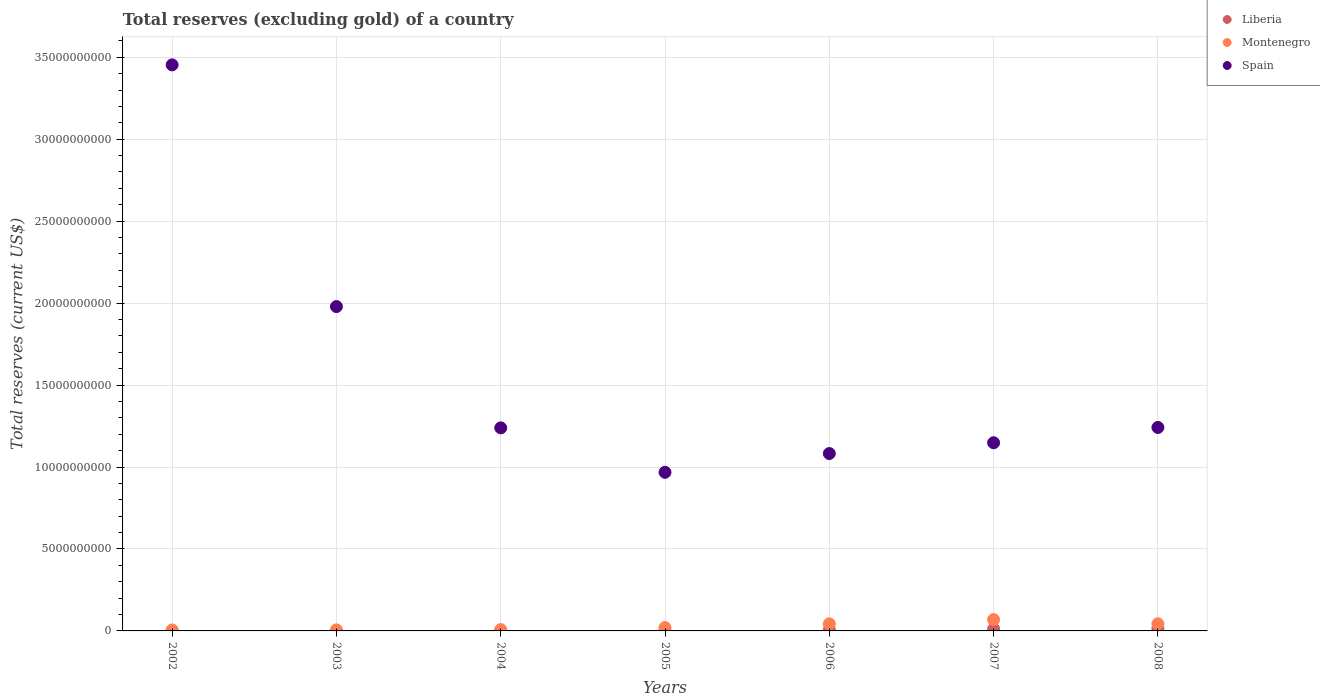Is the number of dotlines equal to the number of legend labels?
Ensure brevity in your answer.  Yes. What is the total reserves (excluding gold) in Spain in 2008?
Give a very brief answer. 1.24e+1. Across all years, what is the maximum total reserves (excluding gold) in Spain?
Offer a very short reply. 3.45e+1. Across all years, what is the minimum total reserves (excluding gold) in Spain?
Make the answer very short. 9.68e+09. In which year was the total reserves (excluding gold) in Liberia maximum?
Offer a very short reply. 2008. In which year was the total reserves (excluding gold) in Liberia minimum?
Offer a terse response. 2002. What is the total total reserves (excluding gold) in Spain in the graph?
Offer a very short reply. 1.11e+11. What is the difference between the total reserves (excluding gold) in Spain in 2007 and that in 2008?
Give a very brief answer. -9.33e+08. What is the difference between the total reserves (excluding gold) in Spain in 2006 and the total reserves (excluding gold) in Montenegro in 2007?
Your response must be concise. 1.01e+1. What is the average total reserves (excluding gold) in Liberia per year?
Offer a very short reply. 5.81e+07. In the year 2007, what is the difference between the total reserves (excluding gold) in Spain and total reserves (excluding gold) in Liberia?
Keep it short and to the point. 1.14e+1. What is the ratio of the total reserves (excluding gold) in Liberia in 2005 to that in 2006?
Make the answer very short. 0.35. What is the difference between the highest and the second highest total reserves (excluding gold) in Spain?
Provide a short and direct response. 1.47e+1. What is the difference between the highest and the lowest total reserves (excluding gold) in Liberia?
Offer a terse response. 1.58e+08. In how many years, is the total reserves (excluding gold) in Liberia greater than the average total reserves (excluding gold) in Liberia taken over all years?
Give a very brief answer. 3. Is the sum of the total reserves (excluding gold) in Montenegro in 2003 and 2007 greater than the maximum total reserves (excluding gold) in Liberia across all years?
Make the answer very short. Yes. Does the total reserves (excluding gold) in Montenegro monotonically increase over the years?
Give a very brief answer. No. Is the total reserves (excluding gold) in Montenegro strictly less than the total reserves (excluding gold) in Spain over the years?
Keep it short and to the point. Yes. How many dotlines are there?
Offer a terse response. 3. What is the difference between two consecutive major ticks on the Y-axis?
Provide a short and direct response. 5.00e+09. Are the values on the major ticks of Y-axis written in scientific E-notation?
Keep it short and to the point. No. Does the graph contain grids?
Your response must be concise. Yes. Where does the legend appear in the graph?
Your response must be concise. Top right. What is the title of the graph?
Give a very brief answer. Total reserves (excluding gold) of a country. Does "Arab World" appear as one of the legend labels in the graph?
Ensure brevity in your answer.  No. What is the label or title of the X-axis?
Your answer should be compact. Years. What is the label or title of the Y-axis?
Give a very brief answer. Total reserves (current US$). What is the Total reserves (current US$) of Liberia in 2002?
Offer a very short reply. 3.30e+06. What is the Total reserves (current US$) of Montenegro in 2002?
Make the answer very short. 5.82e+07. What is the Total reserves (current US$) in Spain in 2002?
Give a very brief answer. 3.45e+1. What is the Total reserves (current US$) of Liberia in 2003?
Ensure brevity in your answer.  7.38e+06. What is the Total reserves (current US$) in Montenegro in 2003?
Offer a terse response. 6.37e+07. What is the Total reserves (current US$) of Spain in 2003?
Give a very brief answer. 1.98e+1. What is the Total reserves (current US$) in Liberia in 2004?
Your response must be concise. 1.87e+07. What is the Total reserves (current US$) of Montenegro in 2004?
Offer a very short reply. 8.18e+07. What is the Total reserves (current US$) of Spain in 2004?
Make the answer very short. 1.24e+1. What is the Total reserves (current US$) in Liberia in 2005?
Offer a terse response. 2.54e+07. What is the Total reserves (current US$) in Montenegro in 2005?
Your response must be concise. 2.04e+08. What is the Total reserves (current US$) of Spain in 2005?
Provide a short and direct response. 9.68e+09. What is the Total reserves (current US$) in Liberia in 2006?
Your answer should be very brief. 7.20e+07. What is the Total reserves (current US$) in Montenegro in 2006?
Make the answer very short. 4.33e+08. What is the Total reserves (current US$) in Spain in 2006?
Provide a succinct answer. 1.08e+1. What is the Total reserves (current US$) of Liberia in 2007?
Your response must be concise. 1.19e+08. What is the Total reserves (current US$) in Montenegro in 2007?
Offer a very short reply. 6.89e+08. What is the Total reserves (current US$) of Spain in 2007?
Provide a succinct answer. 1.15e+1. What is the Total reserves (current US$) in Liberia in 2008?
Provide a short and direct response. 1.61e+08. What is the Total reserves (current US$) in Montenegro in 2008?
Your answer should be compact. 4.36e+08. What is the Total reserves (current US$) of Spain in 2008?
Ensure brevity in your answer.  1.24e+1. Across all years, what is the maximum Total reserves (current US$) of Liberia?
Your response must be concise. 1.61e+08. Across all years, what is the maximum Total reserves (current US$) of Montenegro?
Your response must be concise. 6.89e+08. Across all years, what is the maximum Total reserves (current US$) in Spain?
Your response must be concise. 3.45e+1. Across all years, what is the minimum Total reserves (current US$) of Liberia?
Your answer should be very brief. 3.30e+06. Across all years, what is the minimum Total reserves (current US$) of Montenegro?
Keep it short and to the point. 5.82e+07. Across all years, what is the minimum Total reserves (current US$) in Spain?
Offer a very short reply. 9.68e+09. What is the total Total reserves (current US$) in Liberia in the graph?
Keep it short and to the point. 4.07e+08. What is the total Total reserves (current US$) in Montenegro in the graph?
Make the answer very short. 1.96e+09. What is the total Total reserves (current US$) in Spain in the graph?
Your answer should be compact. 1.11e+11. What is the difference between the Total reserves (current US$) of Liberia in 2002 and that in 2003?
Your response must be concise. -4.08e+06. What is the difference between the Total reserves (current US$) of Montenegro in 2002 and that in 2003?
Your answer should be very brief. -5.52e+06. What is the difference between the Total reserves (current US$) in Spain in 2002 and that in 2003?
Give a very brief answer. 1.47e+1. What is the difference between the Total reserves (current US$) of Liberia in 2002 and that in 2004?
Ensure brevity in your answer.  -1.54e+07. What is the difference between the Total reserves (current US$) in Montenegro in 2002 and that in 2004?
Make the answer very short. -2.36e+07. What is the difference between the Total reserves (current US$) of Spain in 2002 and that in 2004?
Your answer should be compact. 2.21e+1. What is the difference between the Total reserves (current US$) of Liberia in 2002 and that in 2005?
Make the answer very short. -2.21e+07. What is the difference between the Total reserves (current US$) in Montenegro in 2002 and that in 2005?
Ensure brevity in your answer.  -1.46e+08. What is the difference between the Total reserves (current US$) of Spain in 2002 and that in 2005?
Ensure brevity in your answer.  2.49e+1. What is the difference between the Total reserves (current US$) in Liberia in 2002 and that in 2006?
Give a very brief answer. -6.87e+07. What is the difference between the Total reserves (current US$) in Montenegro in 2002 and that in 2006?
Offer a very short reply. -3.74e+08. What is the difference between the Total reserves (current US$) in Spain in 2002 and that in 2006?
Offer a terse response. 2.37e+1. What is the difference between the Total reserves (current US$) of Liberia in 2002 and that in 2007?
Give a very brief answer. -1.16e+08. What is the difference between the Total reserves (current US$) in Montenegro in 2002 and that in 2007?
Provide a short and direct response. -6.31e+08. What is the difference between the Total reserves (current US$) in Spain in 2002 and that in 2007?
Keep it short and to the point. 2.31e+1. What is the difference between the Total reserves (current US$) of Liberia in 2002 and that in 2008?
Offer a terse response. -1.58e+08. What is the difference between the Total reserves (current US$) in Montenegro in 2002 and that in 2008?
Ensure brevity in your answer.  -3.77e+08. What is the difference between the Total reserves (current US$) in Spain in 2002 and that in 2008?
Your response must be concise. 2.21e+1. What is the difference between the Total reserves (current US$) in Liberia in 2003 and that in 2004?
Offer a terse response. -1.14e+07. What is the difference between the Total reserves (current US$) in Montenegro in 2003 and that in 2004?
Offer a terse response. -1.81e+07. What is the difference between the Total reserves (current US$) of Spain in 2003 and that in 2004?
Keep it short and to the point. 7.40e+09. What is the difference between the Total reserves (current US$) of Liberia in 2003 and that in 2005?
Your answer should be compact. -1.80e+07. What is the difference between the Total reserves (current US$) in Montenegro in 2003 and that in 2005?
Offer a very short reply. -1.40e+08. What is the difference between the Total reserves (current US$) of Spain in 2003 and that in 2005?
Give a very brief answer. 1.01e+1. What is the difference between the Total reserves (current US$) in Liberia in 2003 and that in 2006?
Give a very brief answer. -6.46e+07. What is the difference between the Total reserves (current US$) in Montenegro in 2003 and that in 2006?
Keep it short and to the point. -3.69e+08. What is the difference between the Total reserves (current US$) in Spain in 2003 and that in 2006?
Offer a terse response. 8.97e+09. What is the difference between the Total reserves (current US$) of Liberia in 2003 and that in 2007?
Ensure brevity in your answer.  -1.12e+08. What is the difference between the Total reserves (current US$) in Montenegro in 2003 and that in 2007?
Your response must be concise. -6.25e+08. What is the difference between the Total reserves (current US$) in Spain in 2003 and that in 2007?
Your answer should be compact. 8.31e+09. What is the difference between the Total reserves (current US$) of Liberia in 2003 and that in 2008?
Provide a succinct answer. -1.53e+08. What is the difference between the Total reserves (current US$) in Montenegro in 2003 and that in 2008?
Your response must be concise. -3.72e+08. What is the difference between the Total reserves (current US$) in Spain in 2003 and that in 2008?
Ensure brevity in your answer.  7.37e+09. What is the difference between the Total reserves (current US$) of Liberia in 2004 and that in 2005?
Keep it short and to the point. -6.65e+06. What is the difference between the Total reserves (current US$) in Montenegro in 2004 and that in 2005?
Give a very brief answer. -1.22e+08. What is the difference between the Total reserves (current US$) in Spain in 2004 and that in 2005?
Your answer should be very brief. 2.71e+09. What is the difference between the Total reserves (current US$) of Liberia in 2004 and that in 2006?
Make the answer very short. -5.32e+07. What is the difference between the Total reserves (current US$) in Montenegro in 2004 and that in 2006?
Offer a terse response. -3.51e+08. What is the difference between the Total reserves (current US$) in Spain in 2004 and that in 2006?
Your answer should be compact. 1.57e+09. What is the difference between the Total reserves (current US$) of Liberia in 2004 and that in 2007?
Keep it short and to the point. -1.01e+08. What is the difference between the Total reserves (current US$) in Montenegro in 2004 and that in 2007?
Ensure brevity in your answer.  -6.07e+08. What is the difference between the Total reserves (current US$) of Spain in 2004 and that in 2007?
Provide a short and direct response. 9.09e+08. What is the difference between the Total reserves (current US$) in Liberia in 2004 and that in 2008?
Ensure brevity in your answer.  -1.42e+08. What is the difference between the Total reserves (current US$) of Montenegro in 2004 and that in 2008?
Make the answer very short. -3.54e+08. What is the difference between the Total reserves (current US$) of Spain in 2004 and that in 2008?
Provide a short and direct response. -2.48e+07. What is the difference between the Total reserves (current US$) of Liberia in 2005 and that in 2006?
Provide a succinct answer. -4.66e+07. What is the difference between the Total reserves (current US$) in Montenegro in 2005 and that in 2006?
Your response must be concise. -2.29e+08. What is the difference between the Total reserves (current US$) of Spain in 2005 and that in 2006?
Offer a very short reply. -1.14e+09. What is the difference between the Total reserves (current US$) of Liberia in 2005 and that in 2007?
Provide a short and direct response. -9.40e+07. What is the difference between the Total reserves (current US$) in Montenegro in 2005 and that in 2007?
Offer a terse response. -4.85e+08. What is the difference between the Total reserves (current US$) of Spain in 2005 and that in 2007?
Make the answer very short. -1.80e+09. What is the difference between the Total reserves (current US$) in Liberia in 2005 and that in 2008?
Offer a very short reply. -1.35e+08. What is the difference between the Total reserves (current US$) of Montenegro in 2005 and that in 2008?
Give a very brief answer. -2.32e+08. What is the difference between the Total reserves (current US$) of Spain in 2005 and that in 2008?
Provide a short and direct response. -2.74e+09. What is the difference between the Total reserves (current US$) in Liberia in 2006 and that in 2007?
Your response must be concise. -4.74e+07. What is the difference between the Total reserves (current US$) of Montenegro in 2006 and that in 2007?
Offer a very short reply. -2.56e+08. What is the difference between the Total reserves (current US$) in Spain in 2006 and that in 2007?
Your answer should be compact. -6.58e+08. What is the difference between the Total reserves (current US$) in Liberia in 2006 and that in 2008?
Offer a terse response. -8.89e+07. What is the difference between the Total reserves (current US$) of Montenegro in 2006 and that in 2008?
Provide a succinct answer. -3.00e+06. What is the difference between the Total reserves (current US$) of Spain in 2006 and that in 2008?
Offer a terse response. -1.59e+09. What is the difference between the Total reserves (current US$) of Liberia in 2007 and that in 2008?
Offer a terse response. -4.15e+07. What is the difference between the Total reserves (current US$) of Montenegro in 2007 and that in 2008?
Provide a short and direct response. 2.53e+08. What is the difference between the Total reserves (current US$) of Spain in 2007 and that in 2008?
Give a very brief answer. -9.33e+08. What is the difference between the Total reserves (current US$) of Liberia in 2002 and the Total reserves (current US$) of Montenegro in 2003?
Keep it short and to the point. -6.04e+07. What is the difference between the Total reserves (current US$) in Liberia in 2002 and the Total reserves (current US$) in Spain in 2003?
Provide a succinct answer. -1.98e+1. What is the difference between the Total reserves (current US$) in Montenegro in 2002 and the Total reserves (current US$) in Spain in 2003?
Keep it short and to the point. -1.97e+1. What is the difference between the Total reserves (current US$) of Liberia in 2002 and the Total reserves (current US$) of Montenegro in 2004?
Your answer should be very brief. -7.85e+07. What is the difference between the Total reserves (current US$) in Liberia in 2002 and the Total reserves (current US$) in Spain in 2004?
Your response must be concise. -1.24e+1. What is the difference between the Total reserves (current US$) in Montenegro in 2002 and the Total reserves (current US$) in Spain in 2004?
Offer a terse response. -1.23e+1. What is the difference between the Total reserves (current US$) in Liberia in 2002 and the Total reserves (current US$) in Montenegro in 2005?
Your answer should be very brief. -2.01e+08. What is the difference between the Total reserves (current US$) of Liberia in 2002 and the Total reserves (current US$) of Spain in 2005?
Offer a terse response. -9.67e+09. What is the difference between the Total reserves (current US$) of Montenegro in 2002 and the Total reserves (current US$) of Spain in 2005?
Give a very brief answer. -9.62e+09. What is the difference between the Total reserves (current US$) in Liberia in 2002 and the Total reserves (current US$) in Montenegro in 2006?
Provide a short and direct response. -4.29e+08. What is the difference between the Total reserves (current US$) in Liberia in 2002 and the Total reserves (current US$) in Spain in 2006?
Provide a short and direct response. -1.08e+1. What is the difference between the Total reserves (current US$) in Montenegro in 2002 and the Total reserves (current US$) in Spain in 2006?
Provide a succinct answer. -1.08e+1. What is the difference between the Total reserves (current US$) of Liberia in 2002 and the Total reserves (current US$) of Montenegro in 2007?
Ensure brevity in your answer.  -6.86e+08. What is the difference between the Total reserves (current US$) of Liberia in 2002 and the Total reserves (current US$) of Spain in 2007?
Offer a very short reply. -1.15e+1. What is the difference between the Total reserves (current US$) in Montenegro in 2002 and the Total reserves (current US$) in Spain in 2007?
Give a very brief answer. -1.14e+1. What is the difference between the Total reserves (current US$) of Liberia in 2002 and the Total reserves (current US$) of Montenegro in 2008?
Offer a terse response. -4.32e+08. What is the difference between the Total reserves (current US$) of Liberia in 2002 and the Total reserves (current US$) of Spain in 2008?
Your response must be concise. -1.24e+1. What is the difference between the Total reserves (current US$) of Montenegro in 2002 and the Total reserves (current US$) of Spain in 2008?
Make the answer very short. -1.24e+1. What is the difference between the Total reserves (current US$) in Liberia in 2003 and the Total reserves (current US$) in Montenegro in 2004?
Provide a succinct answer. -7.44e+07. What is the difference between the Total reserves (current US$) in Liberia in 2003 and the Total reserves (current US$) in Spain in 2004?
Keep it short and to the point. -1.24e+1. What is the difference between the Total reserves (current US$) in Montenegro in 2003 and the Total reserves (current US$) in Spain in 2004?
Your answer should be compact. -1.23e+1. What is the difference between the Total reserves (current US$) of Liberia in 2003 and the Total reserves (current US$) of Montenegro in 2005?
Offer a very short reply. -1.97e+08. What is the difference between the Total reserves (current US$) in Liberia in 2003 and the Total reserves (current US$) in Spain in 2005?
Make the answer very short. -9.67e+09. What is the difference between the Total reserves (current US$) in Montenegro in 2003 and the Total reserves (current US$) in Spain in 2005?
Your answer should be very brief. -9.61e+09. What is the difference between the Total reserves (current US$) of Liberia in 2003 and the Total reserves (current US$) of Montenegro in 2006?
Offer a terse response. -4.25e+08. What is the difference between the Total reserves (current US$) of Liberia in 2003 and the Total reserves (current US$) of Spain in 2006?
Provide a succinct answer. -1.08e+1. What is the difference between the Total reserves (current US$) of Montenegro in 2003 and the Total reserves (current US$) of Spain in 2006?
Your response must be concise. -1.08e+1. What is the difference between the Total reserves (current US$) in Liberia in 2003 and the Total reserves (current US$) in Montenegro in 2007?
Provide a short and direct response. -6.81e+08. What is the difference between the Total reserves (current US$) of Liberia in 2003 and the Total reserves (current US$) of Spain in 2007?
Your response must be concise. -1.15e+1. What is the difference between the Total reserves (current US$) of Montenegro in 2003 and the Total reserves (current US$) of Spain in 2007?
Your response must be concise. -1.14e+1. What is the difference between the Total reserves (current US$) of Liberia in 2003 and the Total reserves (current US$) of Montenegro in 2008?
Provide a succinct answer. -4.28e+08. What is the difference between the Total reserves (current US$) of Liberia in 2003 and the Total reserves (current US$) of Spain in 2008?
Your answer should be compact. -1.24e+1. What is the difference between the Total reserves (current US$) in Montenegro in 2003 and the Total reserves (current US$) in Spain in 2008?
Make the answer very short. -1.23e+1. What is the difference between the Total reserves (current US$) in Liberia in 2004 and the Total reserves (current US$) in Montenegro in 2005?
Your answer should be very brief. -1.85e+08. What is the difference between the Total reserves (current US$) of Liberia in 2004 and the Total reserves (current US$) of Spain in 2005?
Your answer should be compact. -9.66e+09. What is the difference between the Total reserves (current US$) of Montenegro in 2004 and the Total reserves (current US$) of Spain in 2005?
Provide a short and direct response. -9.60e+09. What is the difference between the Total reserves (current US$) of Liberia in 2004 and the Total reserves (current US$) of Montenegro in 2006?
Provide a succinct answer. -4.14e+08. What is the difference between the Total reserves (current US$) of Liberia in 2004 and the Total reserves (current US$) of Spain in 2006?
Offer a terse response. -1.08e+1. What is the difference between the Total reserves (current US$) in Montenegro in 2004 and the Total reserves (current US$) in Spain in 2006?
Provide a succinct answer. -1.07e+1. What is the difference between the Total reserves (current US$) of Liberia in 2004 and the Total reserves (current US$) of Montenegro in 2007?
Offer a terse response. -6.70e+08. What is the difference between the Total reserves (current US$) of Liberia in 2004 and the Total reserves (current US$) of Spain in 2007?
Your response must be concise. -1.15e+1. What is the difference between the Total reserves (current US$) in Montenegro in 2004 and the Total reserves (current US$) in Spain in 2007?
Make the answer very short. -1.14e+1. What is the difference between the Total reserves (current US$) in Liberia in 2004 and the Total reserves (current US$) in Montenegro in 2008?
Ensure brevity in your answer.  -4.17e+08. What is the difference between the Total reserves (current US$) of Liberia in 2004 and the Total reserves (current US$) of Spain in 2008?
Ensure brevity in your answer.  -1.24e+1. What is the difference between the Total reserves (current US$) in Montenegro in 2004 and the Total reserves (current US$) in Spain in 2008?
Ensure brevity in your answer.  -1.23e+1. What is the difference between the Total reserves (current US$) in Liberia in 2005 and the Total reserves (current US$) in Montenegro in 2006?
Provide a short and direct response. -4.07e+08. What is the difference between the Total reserves (current US$) in Liberia in 2005 and the Total reserves (current US$) in Spain in 2006?
Keep it short and to the point. -1.08e+1. What is the difference between the Total reserves (current US$) of Montenegro in 2005 and the Total reserves (current US$) of Spain in 2006?
Your response must be concise. -1.06e+1. What is the difference between the Total reserves (current US$) in Liberia in 2005 and the Total reserves (current US$) in Montenegro in 2007?
Your response must be concise. -6.63e+08. What is the difference between the Total reserves (current US$) of Liberia in 2005 and the Total reserves (current US$) of Spain in 2007?
Provide a short and direct response. -1.15e+1. What is the difference between the Total reserves (current US$) of Montenegro in 2005 and the Total reserves (current US$) of Spain in 2007?
Your response must be concise. -1.13e+1. What is the difference between the Total reserves (current US$) of Liberia in 2005 and the Total reserves (current US$) of Montenegro in 2008?
Give a very brief answer. -4.10e+08. What is the difference between the Total reserves (current US$) of Liberia in 2005 and the Total reserves (current US$) of Spain in 2008?
Ensure brevity in your answer.  -1.24e+1. What is the difference between the Total reserves (current US$) in Montenegro in 2005 and the Total reserves (current US$) in Spain in 2008?
Offer a terse response. -1.22e+1. What is the difference between the Total reserves (current US$) of Liberia in 2006 and the Total reserves (current US$) of Montenegro in 2007?
Offer a terse response. -6.17e+08. What is the difference between the Total reserves (current US$) in Liberia in 2006 and the Total reserves (current US$) in Spain in 2007?
Make the answer very short. -1.14e+1. What is the difference between the Total reserves (current US$) in Montenegro in 2006 and the Total reserves (current US$) in Spain in 2007?
Offer a terse response. -1.10e+1. What is the difference between the Total reserves (current US$) in Liberia in 2006 and the Total reserves (current US$) in Montenegro in 2008?
Offer a very short reply. -3.64e+08. What is the difference between the Total reserves (current US$) of Liberia in 2006 and the Total reserves (current US$) of Spain in 2008?
Keep it short and to the point. -1.23e+1. What is the difference between the Total reserves (current US$) in Montenegro in 2006 and the Total reserves (current US$) in Spain in 2008?
Your answer should be very brief. -1.20e+1. What is the difference between the Total reserves (current US$) of Liberia in 2007 and the Total reserves (current US$) of Montenegro in 2008?
Your answer should be compact. -3.16e+08. What is the difference between the Total reserves (current US$) of Liberia in 2007 and the Total reserves (current US$) of Spain in 2008?
Make the answer very short. -1.23e+1. What is the difference between the Total reserves (current US$) in Montenegro in 2007 and the Total reserves (current US$) in Spain in 2008?
Offer a terse response. -1.17e+1. What is the average Total reserves (current US$) in Liberia per year?
Your answer should be very brief. 5.81e+07. What is the average Total reserves (current US$) of Montenegro per year?
Make the answer very short. 2.81e+08. What is the average Total reserves (current US$) in Spain per year?
Give a very brief answer. 1.59e+1. In the year 2002, what is the difference between the Total reserves (current US$) of Liberia and Total reserves (current US$) of Montenegro?
Keep it short and to the point. -5.49e+07. In the year 2002, what is the difference between the Total reserves (current US$) in Liberia and Total reserves (current US$) in Spain?
Ensure brevity in your answer.  -3.45e+1. In the year 2002, what is the difference between the Total reserves (current US$) in Montenegro and Total reserves (current US$) in Spain?
Offer a terse response. -3.45e+1. In the year 2003, what is the difference between the Total reserves (current US$) of Liberia and Total reserves (current US$) of Montenegro?
Give a very brief answer. -5.63e+07. In the year 2003, what is the difference between the Total reserves (current US$) of Liberia and Total reserves (current US$) of Spain?
Give a very brief answer. -1.98e+1. In the year 2003, what is the difference between the Total reserves (current US$) of Montenegro and Total reserves (current US$) of Spain?
Provide a succinct answer. -1.97e+1. In the year 2004, what is the difference between the Total reserves (current US$) of Liberia and Total reserves (current US$) of Montenegro?
Your answer should be compact. -6.31e+07. In the year 2004, what is the difference between the Total reserves (current US$) of Liberia and Total reserves (current US$) of Spain?
Offer a terse response. -1.24e+1. In the year 2004, what is the difference between the Total reserves (current US$) in Montenegro and Total reserves (current US$) in Spain?
Your answer should be very brief. -1.23e+1. In the year 2005, what is the difference between the Total reserves (current US$) of Liberia and Total reserves (current US$) of Montenegro?
Offer a very short reply. -1.79e+08. In the year 2005, what is the difference between the Total reserves (current US$) of Liberia and Total reserves (current US$) of Spain?
Provide a short and direct response. -9.65e+09. In the year 2005, what is the difference between the Total reserves (current US$) of Montenegro and Total reserves (current US$) of Spain?
Provide a succinct answer. -9.47e+09. In the year 2006, what is the difference between the Total reserves (current US$) in Liberia and Total reserves (current US$) in Montenegro?
Keep it short and to the point. -3.61e+08. In the year 2006, what is the difference between the Total reserves (current US$) of Liberia and Total reserves (current US$) of Spain?
Offer a terse response. -1.08e+1. In the year 2006, what is the difference between the Total reserves (current US$) of Montenegro and Total reserves (current US$) of Spain?
Provide a short and direct response. -1.04e+1. In the year 2007, what is the difference between the Total reserves (current US$) in Liberia and Total reserves (current US$) in Montenegro?
Give a very brief answer. -5.69e+08. In the year 2007, what is the difference between the Total reserves (current US$) in Liberia and Total reserves (current US$) in Spain?
Your response must be concise. -1.14e+1. In the year 2007, what is the difference between the Total reserves (current US$) in Montenegro and Total reserves (current US$) in Spain?
Offer a terse response. -1.08e+1. In the year 2008, what is the difference between the Total reserves (current US$) in Liberia and Total reserves (current US$) in Montenegro?
Make the answer very short. -2.75e+08. In the year 2008, what is the difference between the Total reserves (current US$) of Liberia and Total reserves (current US$) of Spain?
Ensure brevity in your answer.  -1.23e+1. In the year 2008, what is the difference between the Total reserves (current US$) in Montenegro and Total reserves (current US$) in Spain?
Your answer should be very brief. -1.20e+1. What is the ratio of the Total reserves (current US$) in Liberia in 2002 to that in 2003?
Provide a succinct answer. 0.45. What is the ratio of the Total reserves (current US$) in Montenegro in 2002 to that in 2003?
Provide a short and direct response. 0.91. What is the ratio of the Total reserves (current US$) of Spain in 2002 to that in 2003?
Provide a succinct answer. 1.75. What is the ratio of the Total reserves (current US$) in Liberia in 2002 to that in 2004?
Make the answer very short. 0.18. What is the ratio of the Total reserves (current US$) of Montenegro in 2002 to that in 2004?
Your answer should be compact. 0.71. What is the ratio of the Total reserves (current US$) of Spain in 2002 to that in 2004?
Provide a short and direct response. 2.79. What is the ratio of the Total reserves (current US$) of Liberia in 2002 to that in 2005?
Make the answer very short. 0.13. What is the ratio of the Total reserves (current US$) of Montenegro in 2002 to that in 2005?
Ensure brevity in your answer.  0.29. What is the ratio of the Total reserves (current US$) in Spain in 2002 to that in 2005?
Offer a very short reply. 3.57. What is the ratio of the Total reserves (current US$) in Liberia in 2002 to that in 2006?
Provide a short and direct response. 0.05. What is the ratio of the Total reserves (current US$) of Montenegro in 2002 to that in 2006?
Your answer should be compact. 0.13. What is the ratio of the Total reserves (current US$) in Spain in 2002 to that in 2006?
Your answer should be very brief. 3.19. What is the ratio of the Total reserves (current US$) in Liberia in 2002 to that in 2007?
Offer a very short reply. 0.03. What is the ratio of the Total reserves (current US$) in Montenegro in 2002 to that in 2007?
Your answer should be very brief. 0.08. What is the ratio of the Total reserves (current US$) of Spain in 2002 to that in 2007?
Offer a very short reply. 3.01. What is the ratio of the Total reserves (current US$) of Liberia in 2002 to that in 2008?
Ensure brevity in your answer.  0.02. What is the ratio of the Total reserves (current US$) of Montenegro in 2002 to that in 2008?
Your answer should be compact. 0.13. What is the ratio of the Total reserves (current US$) in Spain in 2002 to that in 2008?
Ensure brevity in your answer.  2.78. What is the ratio of the Total reserves (current US$) in Liberia in 2003 to that in 2004?
Your response must be concise. 0.39. What is the ratio of the Total reserves (current US$) in Montenegro in 2003 to that in 2004?
Offer a very short reply. 0.78. What is the ratio of the Total reserves (current US$) of Spain in 2003 to that in 2004?
Provide a succinct answer. 1.6. What is the ratio of the Total reserves (current US$) in Liberia in 2003 to that in 2005?
Your response must be concise. 0.29. What is the ratio of the Total reserves (current US$) in Montenegro in 2003 to that in 2005?
Your response must be concise. 0.31. What is the ratio of the Total reserves (current US$) of Spain in 2003 to that in 2005?
Your answer should be compact. 2.04. What is the ratio of the Total reserves (current US$) of Liberia in 2003 to that in 2006?
Your answer should be compact. 0.1. What is the ratio of the Total reserves (current US$) in Montenegro in 2003 to that in 2006?
Provide a short and direct response. 0.15. What is the ratio of the Total reserves (current US$) of Spain in 2003 to that in 2006?
Provide a succinct answer. 1.83. What is the ratio of the Total reserves (current US$) in Liberia in 2003 to that in 2007?
Provide a short and direct response. 0.06. What is the ratio of the Total reserves (current US$) in Montenegro in 2003 to that in 2007?
Offer a terse response. 0.09. What is the ratio of the Total reserves (current US$) in Spain in 2003 to that in 2007?
Your response must be concise. 1.72. What is the ratio of the Total reserves (current US$) in Liberia in 2003 to that in 2008?
Offer a very short reply. 0.05. What is the ratio of the Total reserves (current US$) in Montenegro in 2003 to that in 2008?
Your answer should be compact. 0.15. What is the ratio of the Total reserves (current US$) of Spain in 2003 to that in 2008?
Keep it short and to the point. 1.59. What is the ratio of the Total reserves (current US$) of Liberia in 2004 to that in 2005?
Provide a succinct answer. 0.74. What is the ratio of the Total reserves (current US$) in Montenegro in 2004 to that in 2005?
Provide a short and direct response. 0.4. What is the ratio of the Total reserves (current US$) in Spain in 2004 to that in 2005?
Your response must be concise. 1.28. What is the ratio of the Total reserves (current US$) in Liberia in 2004 to that in 2006?
Provide a succinct answer. 0.26. What is the ratio of the Total reserves (current US$) in Montenegro in 2004 to that in 2006?
Offer a very short reply. 0.19. What is the ratio of the Total reserves (current US$) in Spain in 2004 to that in 2006?
Provide a succinct answer. 1.14. What is the ratio of the Total reserves (current US$) of Liberia in 2004 to that in 2007?
Offer a terse response. 0.16. What is the ratio of the Total reserves (current US$) in Montenegro in 2004 to that in 2007?
Your response must be concise. 0.12. What is the ratio of the Total reserves (current US$) of Spain in 2004 to that in 2007?
Give a very brief answer. 1.08. What is the ratio of the Total reserves (current US$) in Liberia in 2004 to that in 2008?
Offer a terse response. 0.12. What is the ratio of the Total reserves (current US$) of Montenegro in 2004 to that in 2008?
Your answer should be very brief. 0.19. What is the ratio of the Total reserves (current US$) of Liberia in 2005 to that in 2006?
Keep it short and to the point. 0.35. What is the ratio of the Total reserves (current US$) of Montenegro in 2005 to that in 2006?
Your answer should be compact. 0.47. What is the ratio of the Total reserves (current US$) of Spain in 2005 to that in 2006?
Provide a succinct answer. 0.89. What is the ratio of the Total reserves (current US$) in Liberia in 2005 to that in 2007?
Make the answer very short. 0.21. What is the ratio of the Total reserves (current US$) in Montenegro in 2005 to that in 2007?
Ensure brevity in your answer.  0.3. What is the ratio of the Total reserves (current US$) in Spain in 2005 to that in 2007?
Your answer should be very brief. 0.84. What is the ratio of the Total reserves (current US$) of Liberia in 2005 to that in 2008?
Provide a short and direct response. 0.16. What is the ratio of the Total reserves (current US$) in Montenegro in 2005 to that in 2008?
Provide a short and direct response. 0.47. What is the ratio of the Total reserves (current US$) in Spain in 2005 to that in 2008?
Make the answer very short. 0.78. What is the ratio of the Total reserves (current US$) in Liberia in 2006 to that in 2007?
Your answer should be very brief. 0.6. What is the ratio of the Total reserves (current US$) in Montenegro in 2006 to that in 2007?
Your answer should be very brief. 0.63. What is the ratio of the Total reserves (current US$) of Spain in 2006 to that in 2007?
Provide a short and direct response. 0.94. What is the ratio of the Total reserves (current US$) in Liberia in 2006 to that in 2008?
Your answer should be very brief. 0.45. What is the ratio of the Total reserves (current US$) in Spain in 2006 to that in 2008?
Keep it short and to the point. 0.87. What is the ratio of the Total reserves (current US$) in Liberia in 2007 to that in 2008?
Make the answer very short. 0.74. What is the ratio of the Total reserves (current US$) in Montenegro in 2007 to that in 2008?
Give a very brief answer. 1.58. What is the ratio of the Total reserves (current US$) of Spain in 2007 to that in 2008?
Make the answer very short. 0.92. What is the difference between the highest and the second highest Total reserves (current US$) in Liberia?
Provide a succinct answer. 4.15e+07. What is the difference between the highest and the second highest Total reserves (current US$) in Montenegro?
Provide a succinct answer. 2.53e+08. What is the difference between the highest and the second highest Total reserves (current US$) of Spain?
Offer a terse response. 1.47e+1. What is the difference between the highest and the lowest Total reserves (current US$) in Liberia?
Your response must be concise. 1.58e+08. What is the difference between the highest and the lowest Total reserves (current US$) in Montenegro?
Give a very brief answer. 6.31e+08. What is the difference between the highest and the lowest Total reserves (current US$) in Spain?
Offer a terse response. 2.49e+1. 